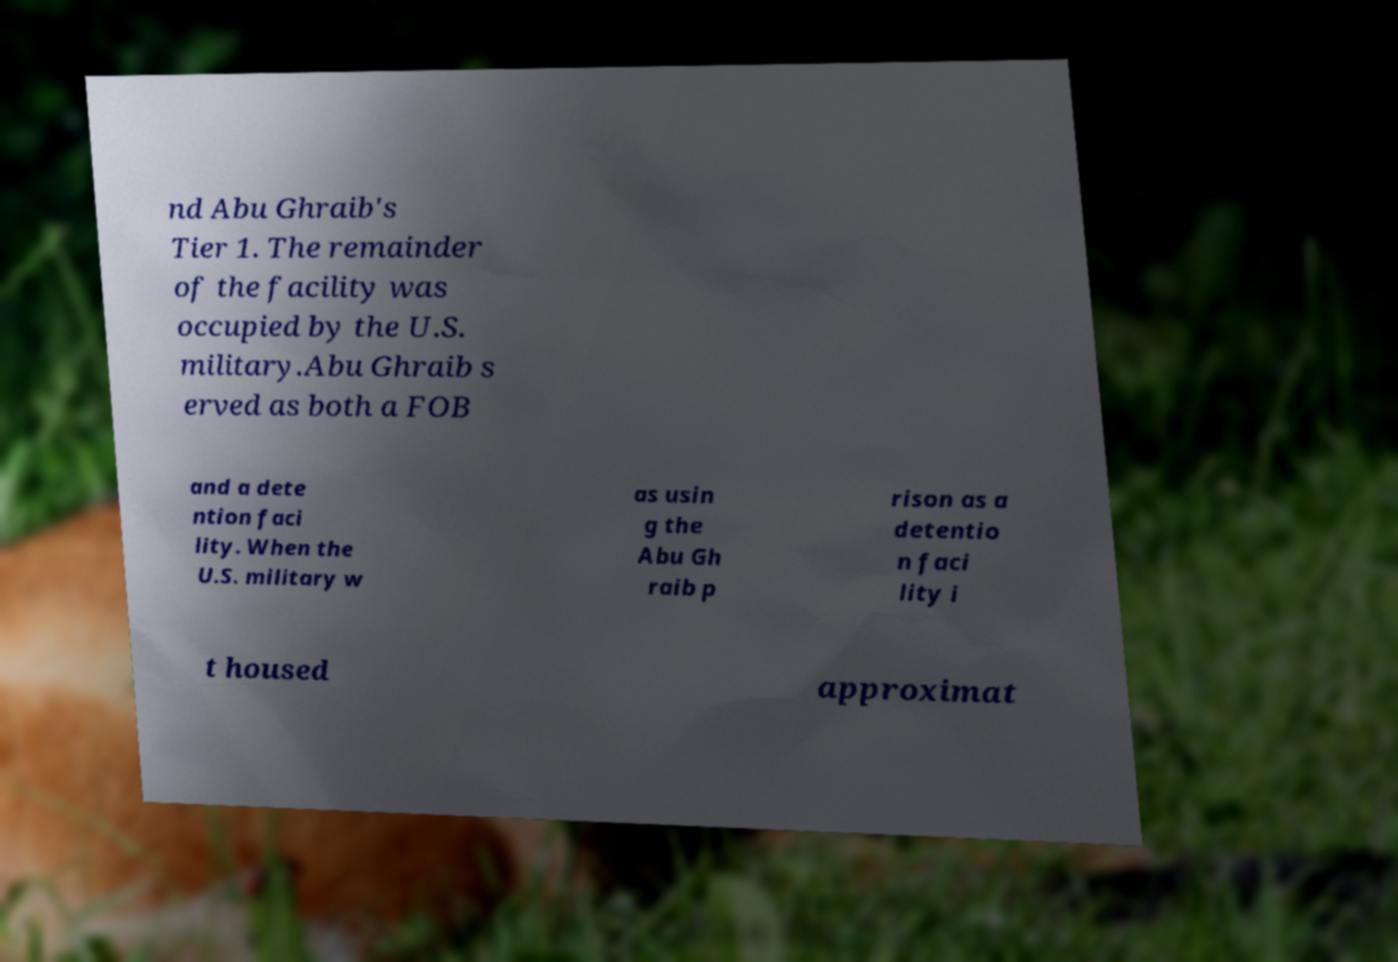There's text embedded in this image that I need extracted. Can you transcribe it verbatim? nd Abu Ghraib's Tier 1. The remainder of the facility was occupied by the U.S. military.Abu Ghraib s erved as both a FOB and a dete ntion faci lity. When the U.S. military w as usin g the Abu Gh raib p rison as a detentio n faci lity i t housed approximat 